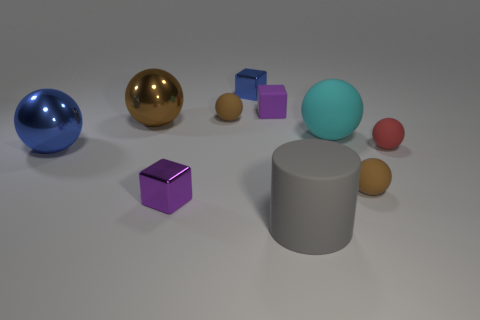Are the red ball and the small ball left of the cyan thing made of the same material?
Ensure brevity in your answer.  Yes. How many tiny objects are to the left of the gray cylinder and in front of the cyan object?
Ensure brevity in your answer.  1. There is a blue metal thing that is the same size as the cyan sphere; what shape is it?
Provide a succinct answer. Sphere. There is a big rubber object behind the small sphere in front of the small red ball; are there any gray rubber cylinders to the left of it?
Provide a succinct answer. Yes. There is a cylinder; does it have the same color as the matte ball that is on the left side of the gray matte object?
Make the answer very short. No. How many other rubber cylinders have the same color as the large cylinder?
Offer a very short reply. 0. There is a purple thing behind the small brown rubber ball that is to the left of the gray thing; how big is it?
Provide a short and direct response. Small. How many objects are small rubber objects in front of the big blue sphere or large gray rubber things?
Offer a very short reply. 2. Is there a ball of the same size as the red rubber thing?
Your response must be concise. Yes. There is a small brown thing that is on the left side of the gray thing; are there any cyan rubber balls that are right of it?
Offer a terse response. Yes. 